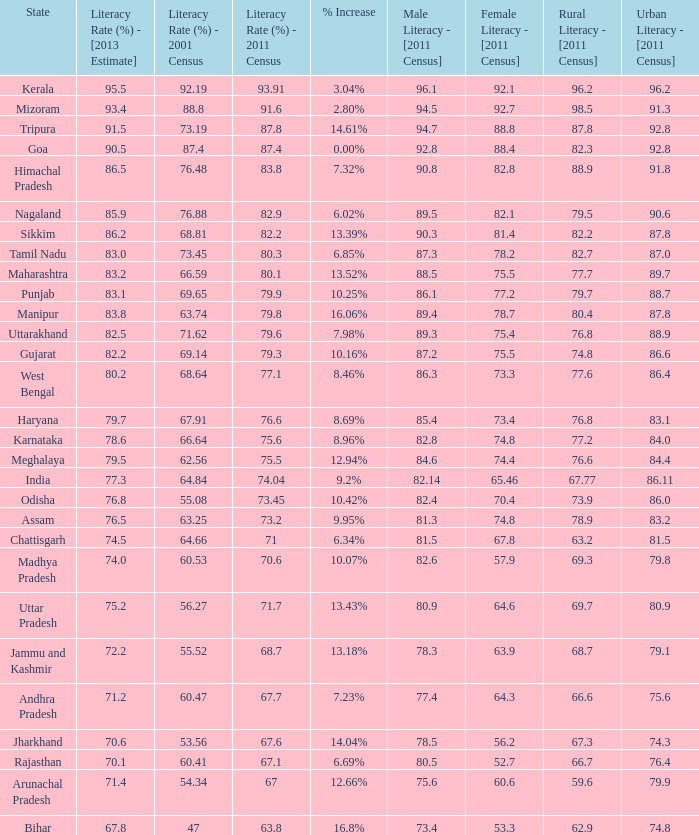Could you help me parse every detail presented in this table? {'header': ['State', 'Literacy Rate (%) - [2013 Estimate]', 'Literacy Rate (%) - 2001 Census', 'Literacy Rate (%) - 2011 Census', '% Increase', 'Male Literacy - [2011 Census]', 'Female Literacy - [2011 Census]', 'Rural Literacy - [2011 Census]', 'Urban Literacy - [2011 Census]'], 'rows': [['Kerala', '95.5', '92.19', '93.91', '3.04%', '96.1', '92.1', '96.2', '96.2'], ['Mizoram', '93.4', '88.8', '91.6', '2.80%', '94.5', '92.7', '98.5', '91.3'], ['Tripura', '91.5', '73.19', '87.8', '14.61%', '94.7', '88.8', '87.8', '92.8'], ['Goa', '90.5', '87.4', '87.4', '0.00%', '92.8', '88.4', '82.3', '92.8'], ['Himachal Pradesh', '86.5', '76.48', '83.8', '7.32%', '90.8', '82.8', '88.9', '91.8'], ['Nagaland', '85.9', '76.88', '82.9', '6.02%', '89.5', '82.1', '79.5', '90.6'], ['Sikkim', '86.2', '68.81', '82.2', '13.39%', '90.3', '81.4', '82.2', '87.8'], ['Tamil Nadu', '83.0', '73.45', '80.3', '6.85%', '87.3', '78.2', '82.7', '87.0'], ['Maharashtra', '83.2', '66.59', '80.1', '13.52%', '88.5', '75.5', '77.7', '89.7'], ['Punjab', '83.1', '69.65', '79.9', '10.25%', '86.1', '77.2', '79.7', '88.7'], ['Manipur', '83.8', '63.74', '79.8', '16.06%', '89.4', '78.7', '80.4', '87.8'], ['Uttarakhand', '82.5', '71.62', '79.6', '7.98%', '89.3', '75.4', '76.8', '88.9'], ['Gujarat', '82.2', '69.14', '79.3', '10.16%', '87.2', '75.5', '74.8', '86.6'], ['West Bengal', '80.2', '68.64', '77.1', '8.46%', '86.3', '73.3', '77.6', '86.4'], ['Haryana', '79.7', '67.91', '76.6', '8.69%', '85.4', '73.4', '76.8', '83.1'], ['Karnataka', '78.6', '66.64', '75.6', '8.96%', '82.8', '74.8', '77.2', '84.0'], ['Meghalaya', '79.5', '62.56', '75.5', '12.94%', '84.6', '74.4', '76.6', '84.4'], ['India', '77.3', '64.84', '74.04', '9.2%', '82.14', '65.46', '67.77', '86.11'], ['Odisha', '76.8', '55.08', '73.45', '10.42%', '82.4', '70.4', '73.9', '86.0'], ['Assam', '76.5', '63.25', '73.2', '9.95%', '81.3', '74.8', '78.9', '83.2'], ['Chattisgarh', '74.5', '64.66', '71', '6.34%', '81.5', '67.8', '63.2', '81.5'], ['Madhya Pradesh', '74.0', '60.53', '70.6', '10.07%', '82.6', '57.9', '69.3', '79.8'], ['Uttar Pradesh', '75.2', '56.27', '71.7', '13.43%', '80.9', '64.6', '69.7', '80.9'], ['Jammu and Kashmir', '72.2', '55.52', '68.7', '13.18%', '78.3', '63.9', '68.7', '79.1'], ['Andhra Pradesh', '71.2', '60.47', '67.7', '7.23%', '77.4', '64.3', '66.6', '75.6'], ['Jharkhand', '70.6', '53.56', '67.6', '14.04%', '78.5', '56.2', '67.3', '74.3'], ['Rajasthan', '70.1', '60.41', '67.1', '6.69%', '80.5', '52.7', '66.7', '76.4'], ['Arunachal Pradesh', '71.4', '54.34', '67', '12.66%', '75.6', '60.6', '59.6', '79.9'], ['Bihar', '67.8', '47', '63.8', '16.8%', '73.4', '53.3', '62.9', '74.8']]} What was the literacy rate published in the 2001 census for the state that saw a 12.66% increase? 54.34. 